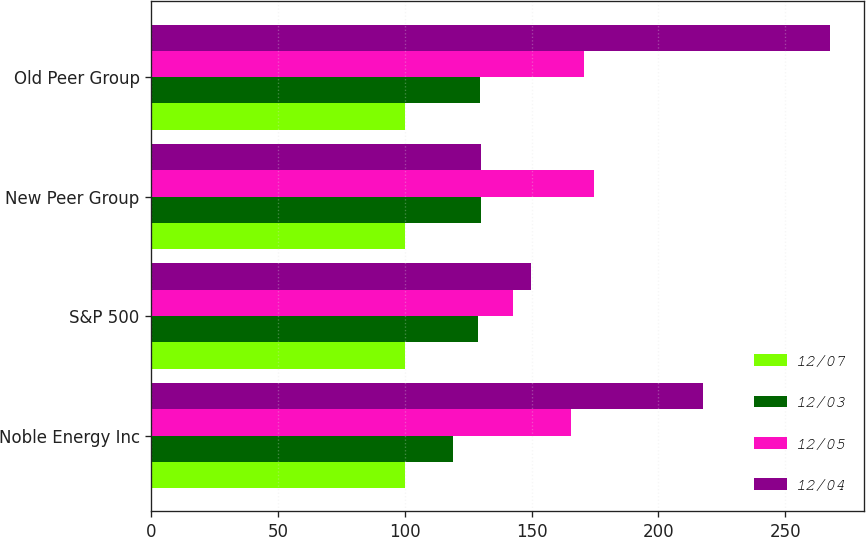Convert chart. <chart><loc_0><loc_0><loc_500><loc_500><stacked_bar_chart><ecel><fcel>Noble Energy Inc<fcel>S&P 500<fcel>New Peer Group<fcel>Old Peer Group<nl><fcel>12/07<fcel>100<fcel>100<fcel>100<fcel>100<nl><fcel>12/03<fcel>118.88<fcel>128.68<fcel>129.82<fcel>129.53<nl><fcel>12/05<fcel>165.66<fcel>142.69<fcel>174.5<fcel>170.44<nl><fcel>12/04<fcel>217.4<fcel>149.7<fcel>129.82<fcel>267.61<nl></chart> 